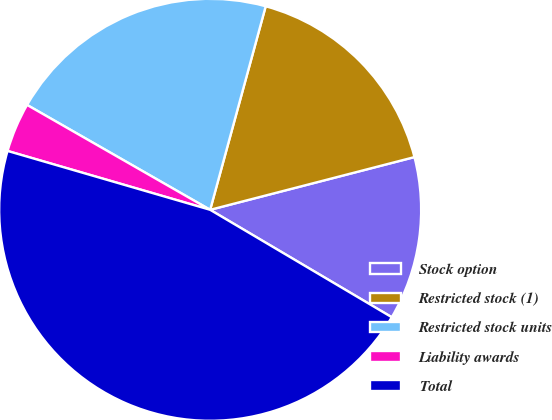Convert chart to OTSL. <chart><loc_0><loc_0><loc_500><loc_500><pie_chart><fcel>Stock option<fcel>Restricted stock (1)<fcel>Restricted stock units<fcel>Liability awards<fcel>Total<nl><fcel>12.52%<fcel>16.74%<fcel>20.96%<fcel>3.78%<fcel>46.0%<nl></chart> 